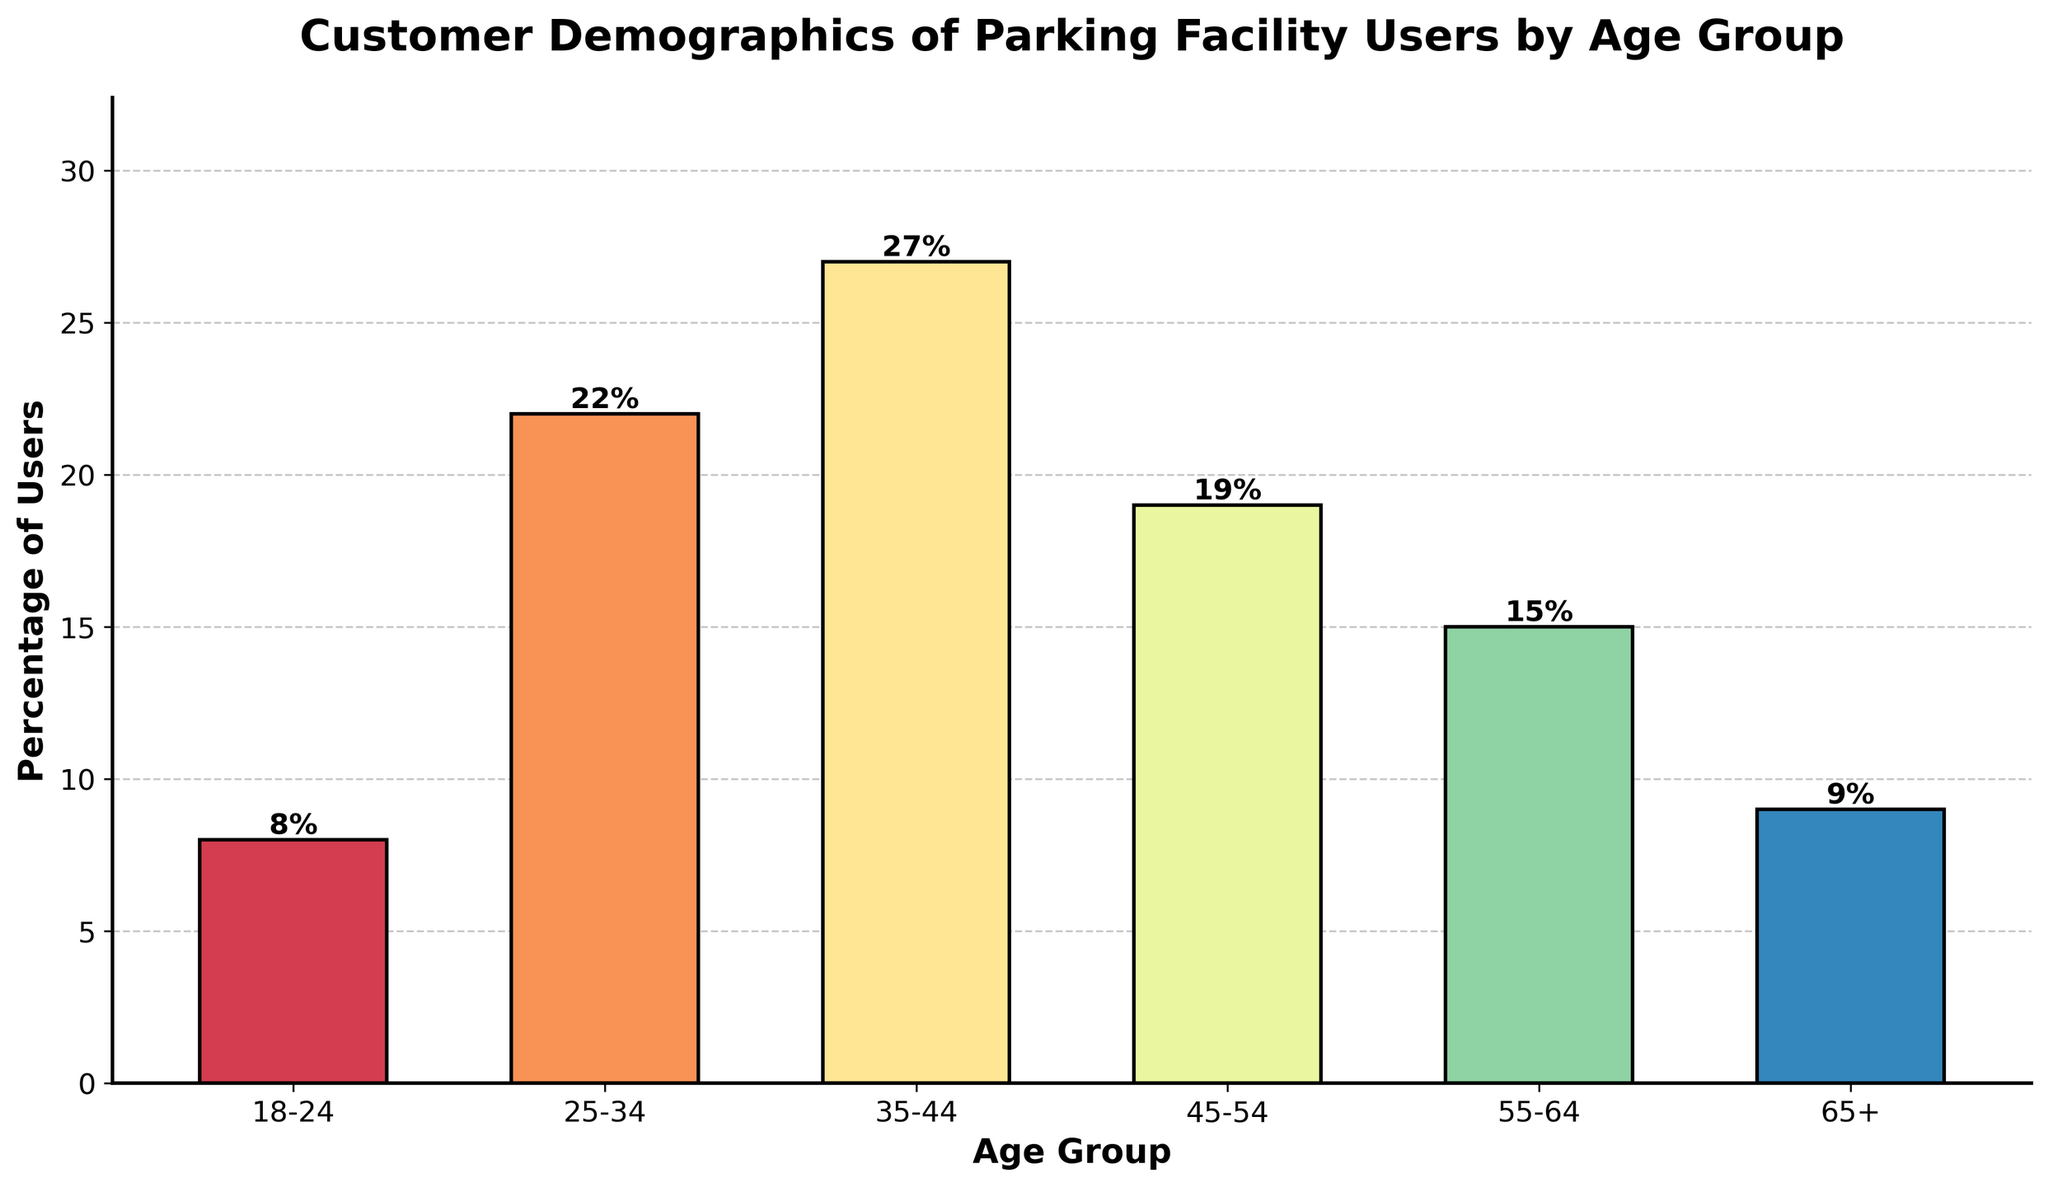What percentage of parking facility users is in the 35-44 age group? Look at the bar corresponding to the 35-44 age group, which shows 27%.
Answer: 27% Which age group has the highest percentage of users? Identify the tallest bar in the chart, which represents the 35-44 age group at 27%.
Answer: 35-44 How much greater is the percentage of users in the 35-44 age group compared to the 18-24 age group? Subtract the percentage of the 18-24 age group (8%) from the 35-44 age group (27%): 27% - 8% = 19%.
Answer: 19% What is the combined percentage of users in the age groups 25-34 and 35-44? Add the percentages of the 25-34 (22%) and 35-44 (27%) age groups: 22% + 27% = 49%.
Answer: 49% Which age group has the lowest percentage of users? Identify the shortest bar in the chart, representing the 18-24 age group at 8%.
Answer: 18-24 Is the percentage of users in the 55-64 age group greater than in the 65+ age group? Compare the heights of the bars for the 55-64 and 65+ age groups; the 55-64 age group (15%) is greater than the 65+ age group (9%).
Answer: Yes What is the average percentage of users across all age groups? Sum all the percentages (8% + 22% + 27% + 19% + 15% + 9% = 100%) and divide by the number of age groups (6): 100% / 6 ≈ 16.67%.
Answer: 16.67% How many age groups have a percentage of users greater than 20%? Identify the bars with percentages above 20%, which are the 25-34 age group (22%) and the 35-44 age group (27%): 2 age groups.
Answer: 2 Which age groups have a similar percentage of users? Compare the heights of the bars; the 18-24 (8%) and 65+ (9%) age groups have similar percentages, and the 45-54 (19%) and 55-64 (15%) are also close.
Answer: 18-24 and 65+, 45-54 and 55-64 